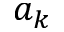Convert formula to latex. <formula><loc_0><loc_0><loc_500><loc_500>a _ { k }</formula> 